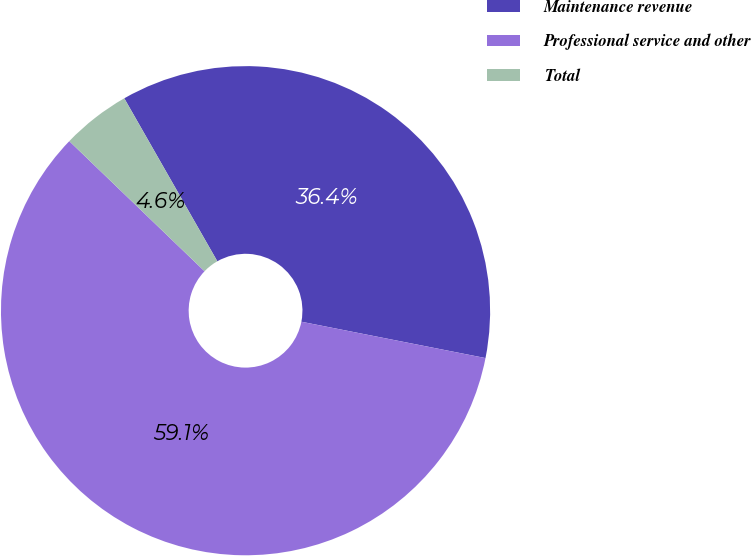Convert chart. <chart><loc_0><loc_0><loc_500><loc_500><pie_chart><fcel>Maintenance revenue<fcel>Professional service and other<fcel>Total<nl><fcel>36.36%<fcel>59.09%<fcel>4.55%<nl></chart> 